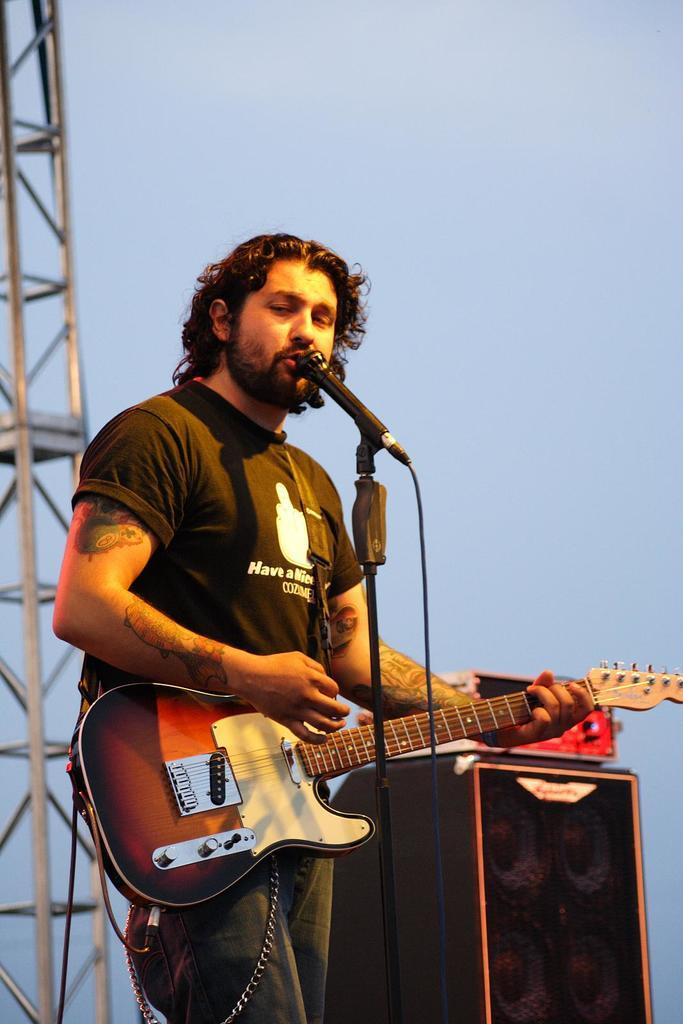What is the main subject in the foreground of the image? There is a person in the foreground of the image. What is the person doing in the image? The person is playing a guitar. What object is present in the image that is typically used for amplifying sound? There is a microphone in the image. What can be seen in the background of the image? The background of the image is the sky. What type of prose can be heard being recited in the image? There is no prose being recited in the image; the person is playing a guitar. How many numbers are visible on the guitar in the image? There are no numbers visible on the guitar in the image; it is a musical instrument used for playing music. 